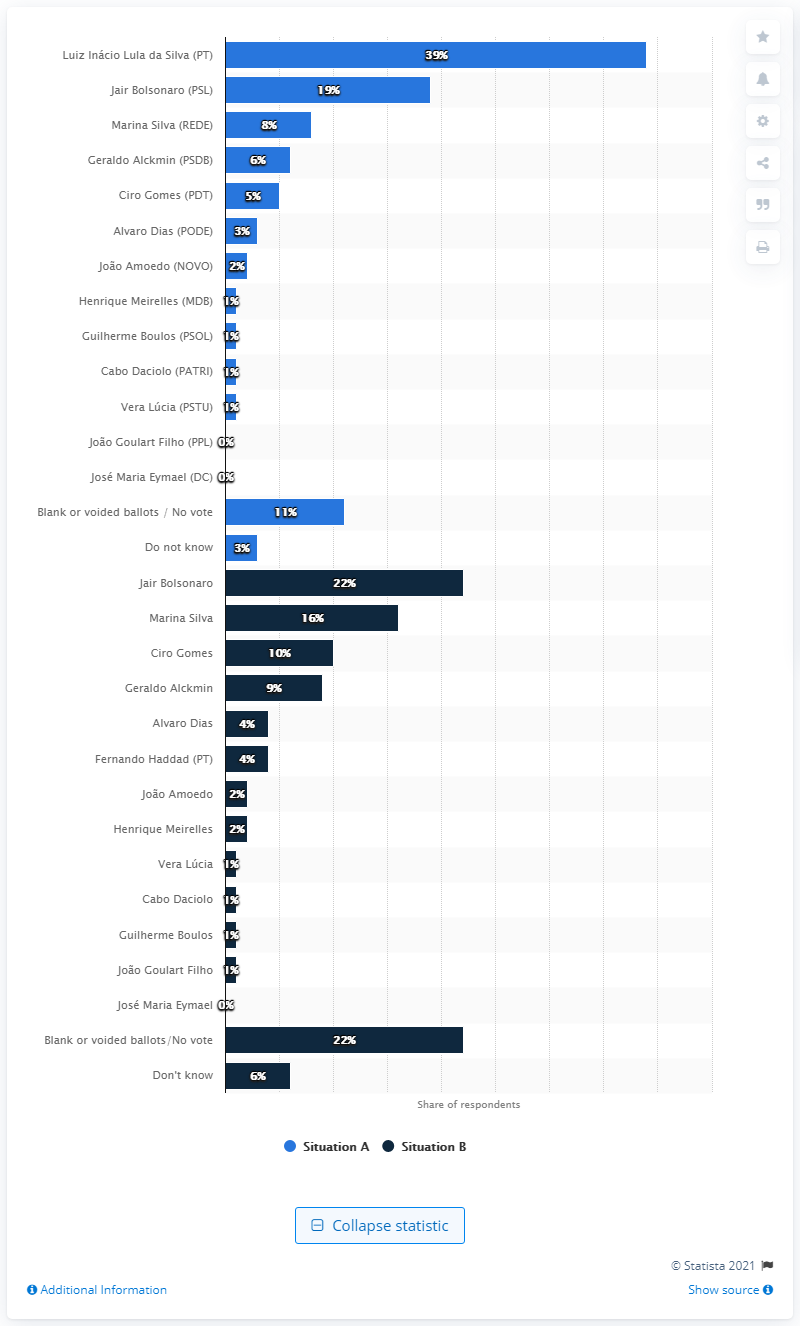Indicate a few pertinent items in this graphic. Marina Silva was the most likely candidate to vote in the first round of Brazil's presidential elections. 